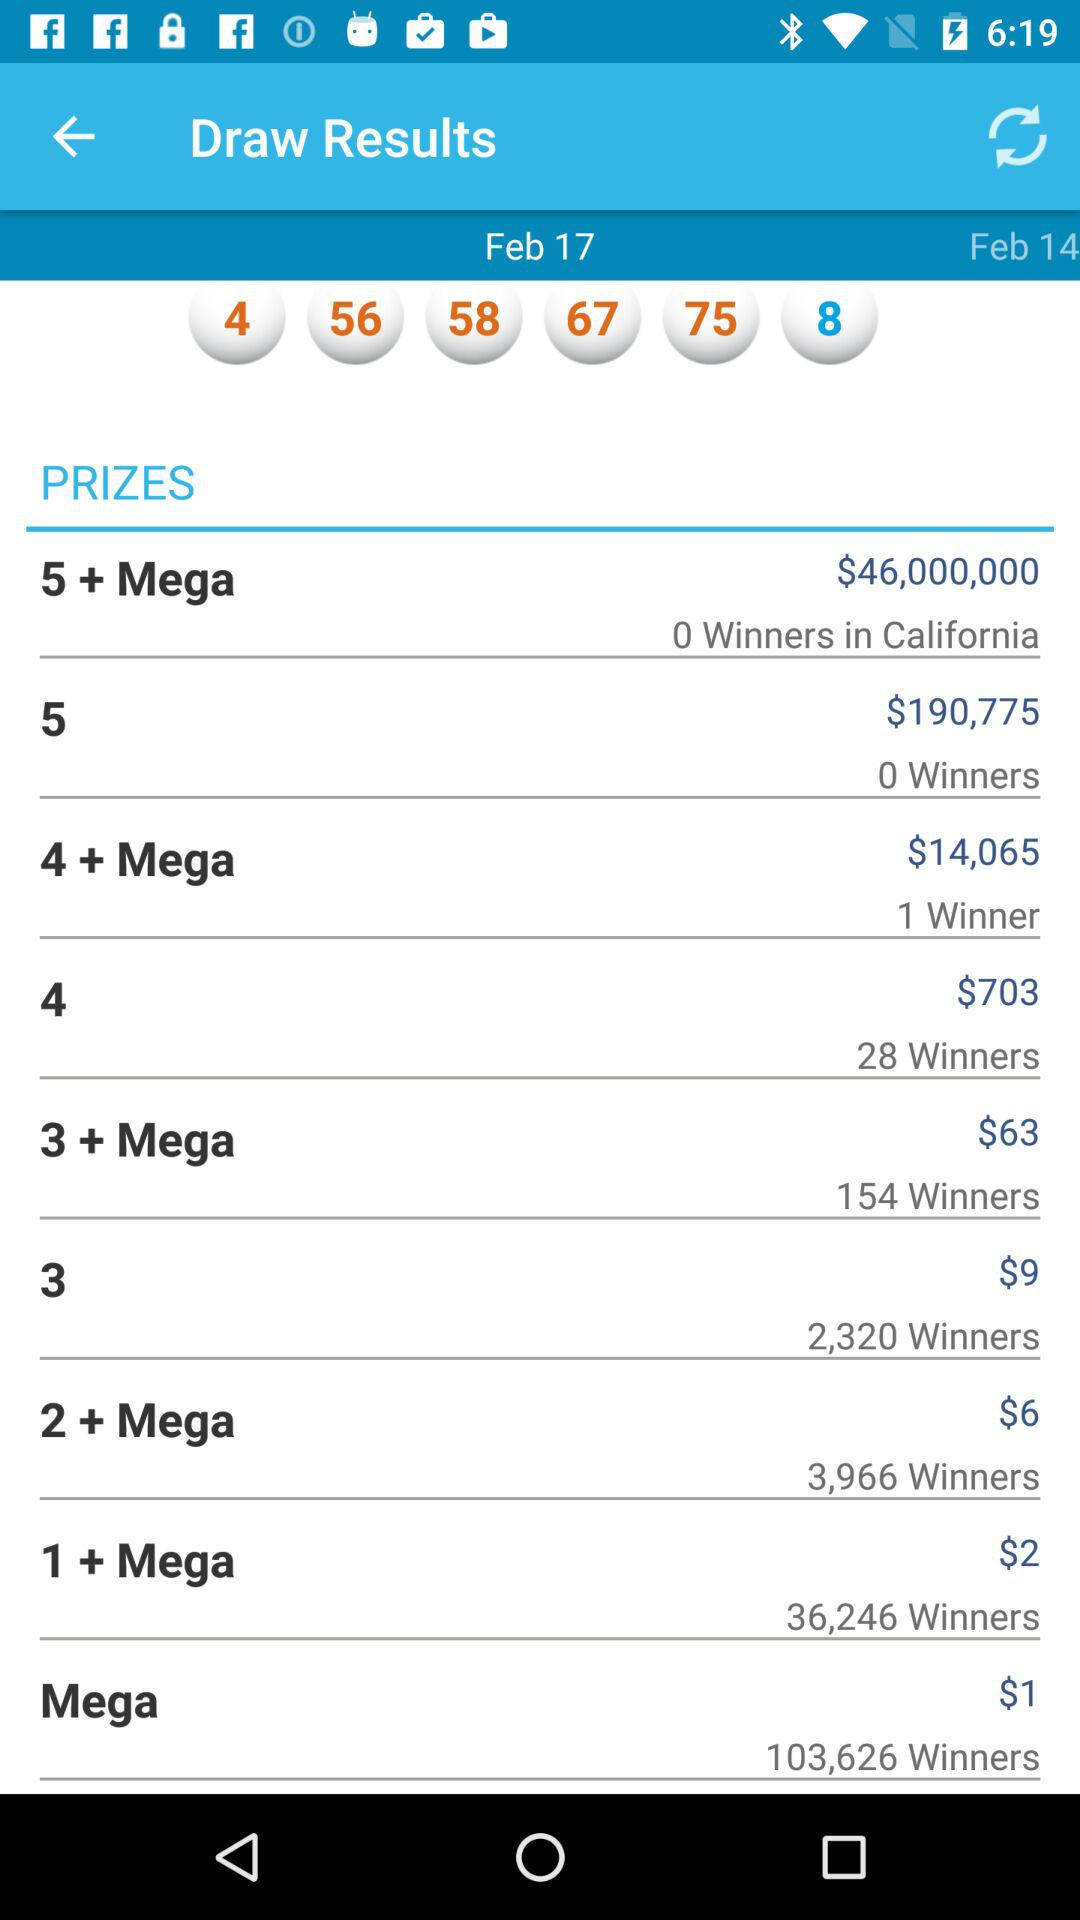How many dollars are given to those who win 3 prizes? Those who win 3 prizes are given 9 dollars. 